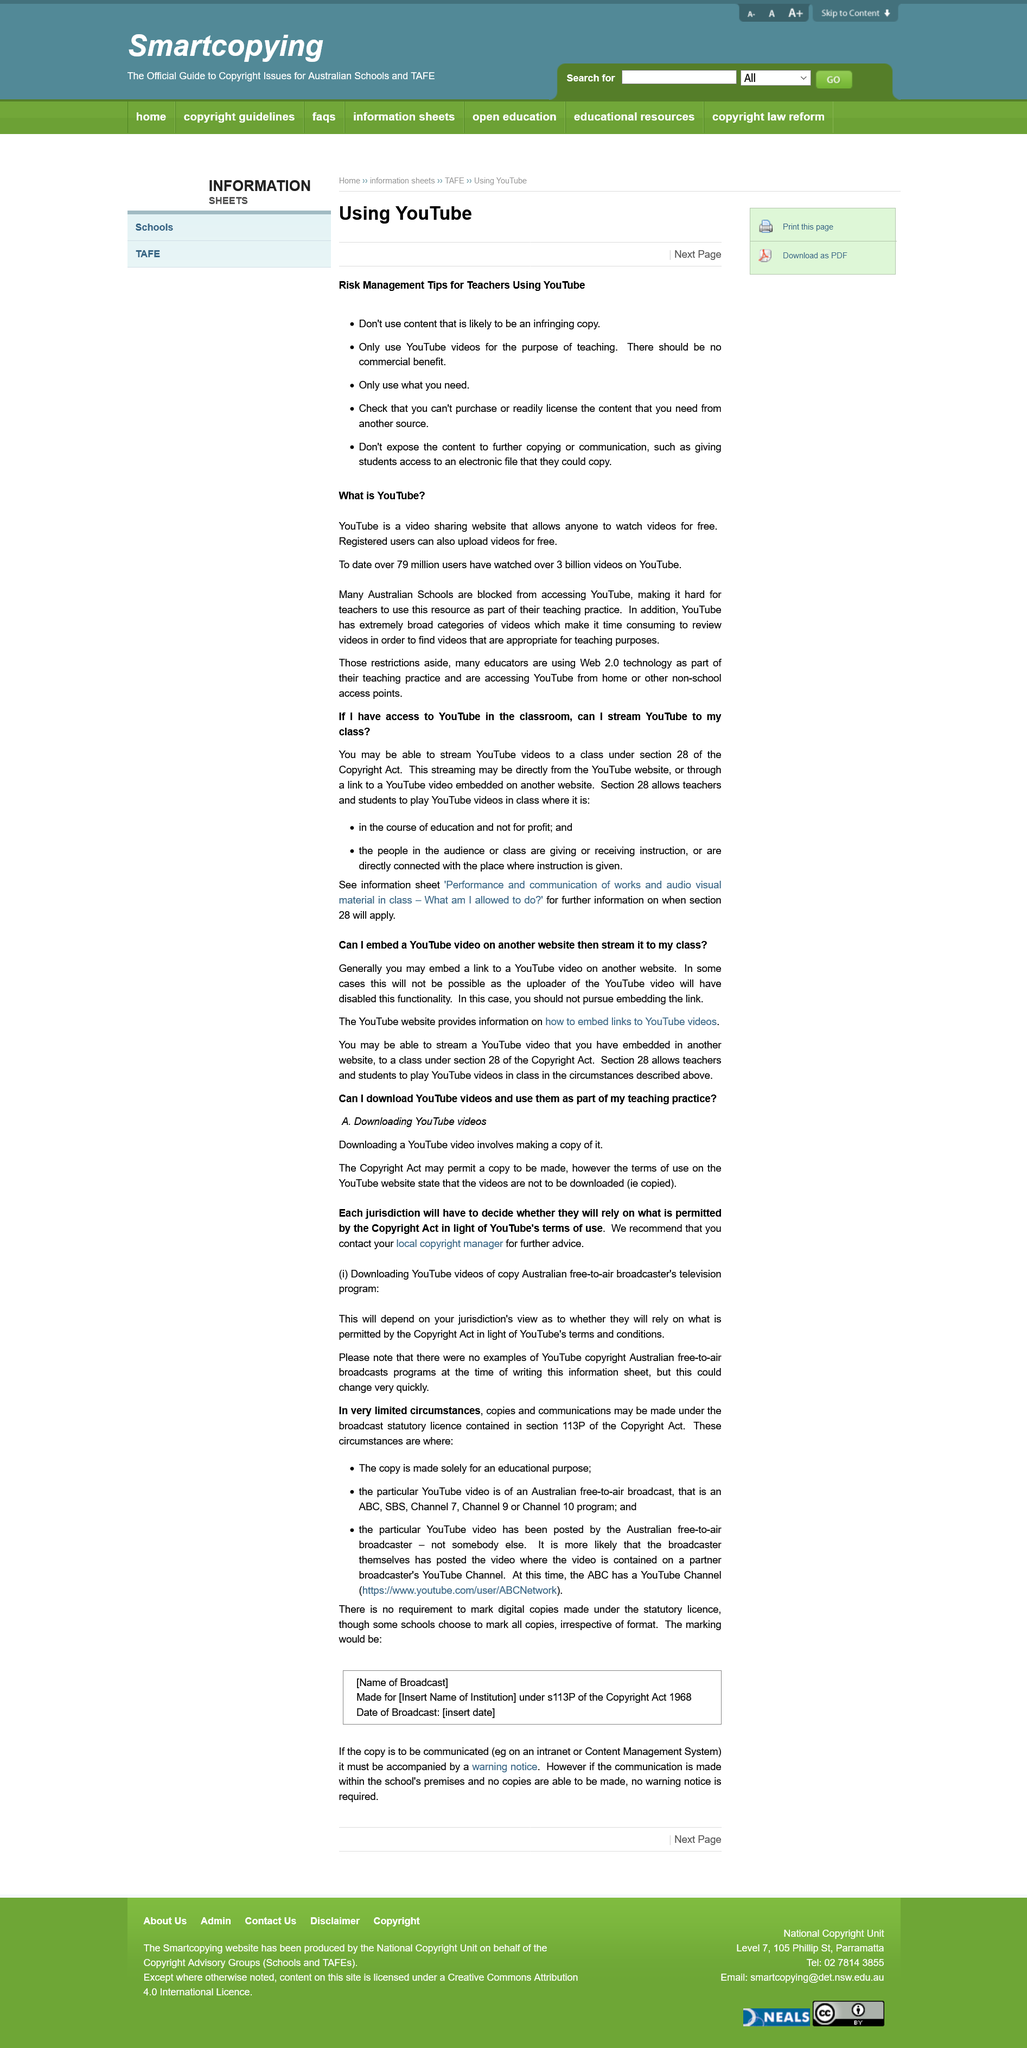List a handful of essential elements in this visual. The article is discussing management tips that relate to risk. YouTube is a website that enables users to access and view various videos for free. The tips are intended for teachers. YouTube is the social media platform that is being discussed in the article. It is not possible to embed Youtube videos on another website or download Youtube videos for teaching purposes. 